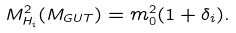<formula> <loc_0><loc_0><loc_500><loc_500>M ^ { 2 } _ { H _ { i } } ( M _ { G U T } ) = m _ { 0 } ^ { 2 } ( 1 + \delta _ { i } ) .</formula> 